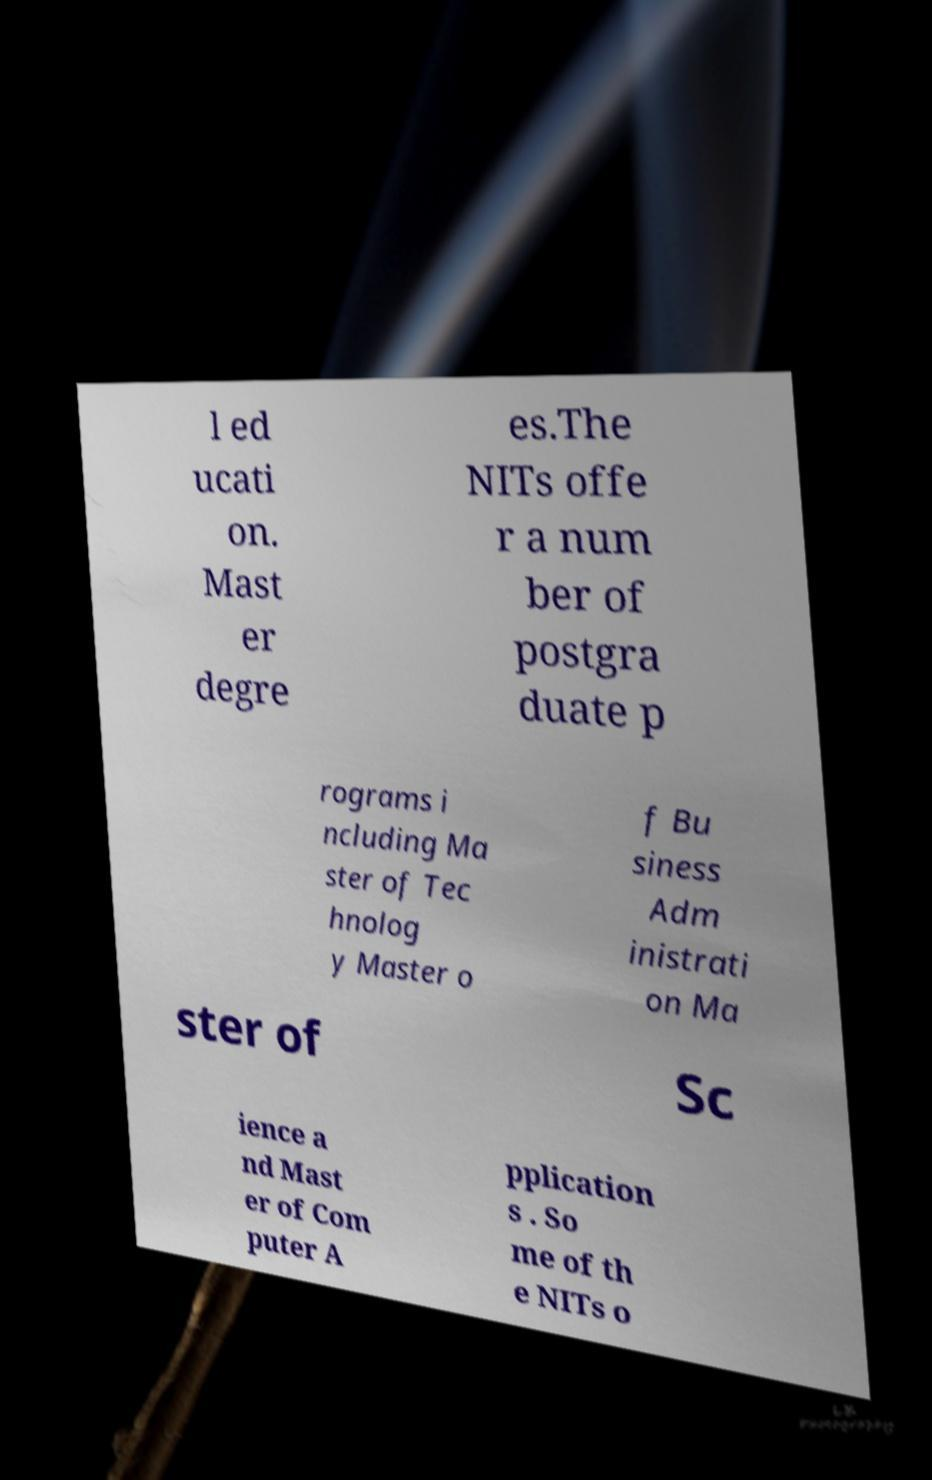For documentation purposes, I need the text within this image transcribed. Could you provide that? l ed ucati on. Mast er degre es.The NITs offe r a num ber of postgra duate p rograms i ncluding Ma ster of Tec hnolog y Master o f Bu siness Adm inistrati on Ma ster of Sc ience a nd Mast er of Com puter A pplication s . So me of th e NITs o 